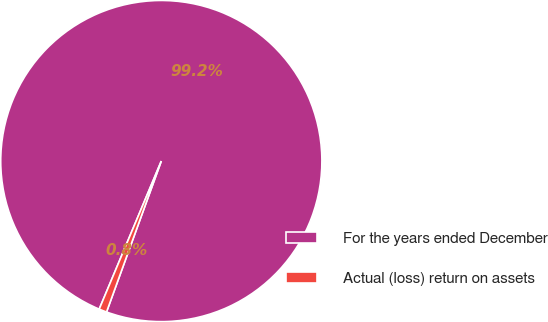Convert chart. <chart><loc_0><loc_0><loc_500><loc_500><pie_chart><fcel>For the years ended December<fcel>Actual (loss) return on assets<nl><fcel>99.22%<fcel>0.78%<nl></chart> 